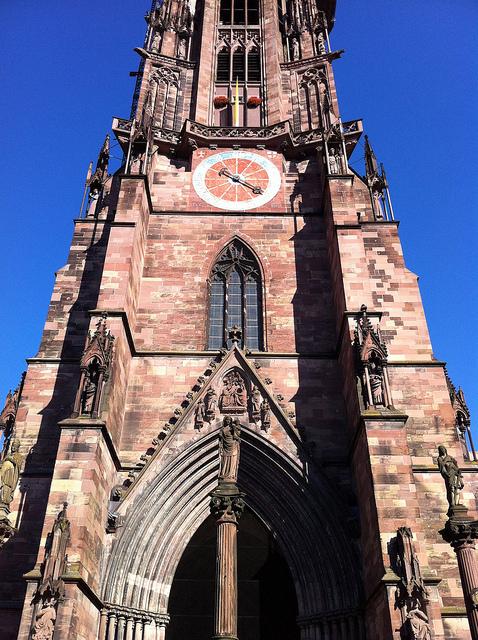Do you think this is a historical monument?
Quick response, please. Yes. Is there a clock on the building?
Concise answer only. Yes. Is this picture taken during the day or night?
Quick response, please. Day. 